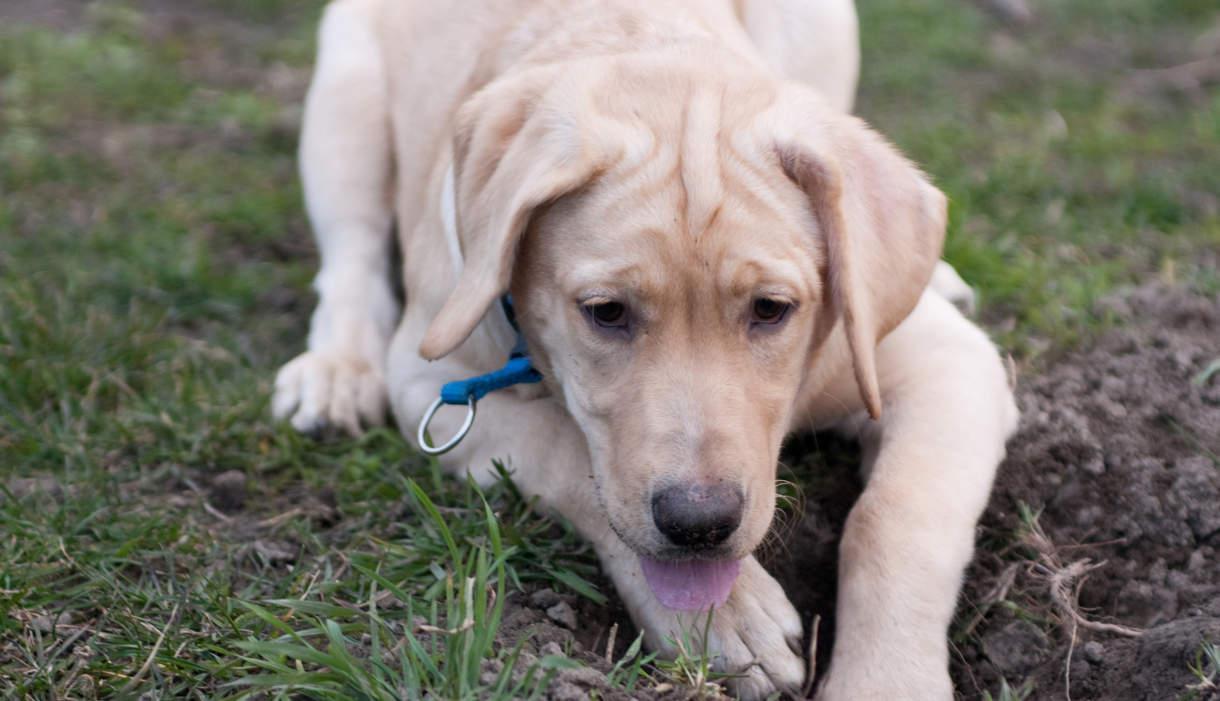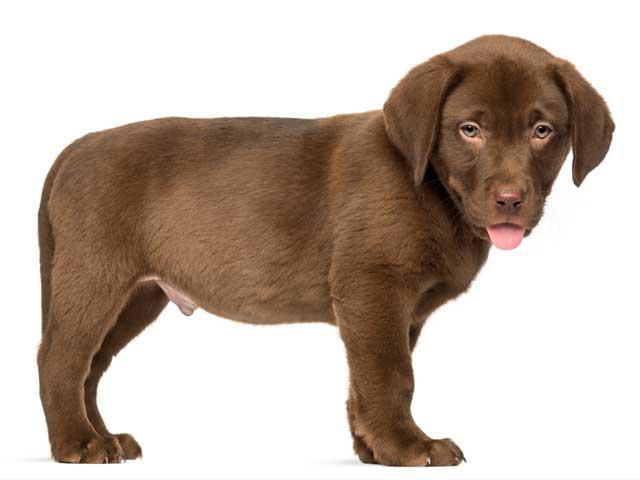The first image is the image on the left, the second image is the image on the right. Evaluate the accuracy of this statement regarding the images: "There is exactly one adult dog lying in the grass.". Is it true? Answer yes or no. Yes. The first image is the image on the left, the second image is the image on the right. For the images displayed, is the sentence "There is exactly one sitting dog in one of the images." factually correct? Answer yes or no. No. 